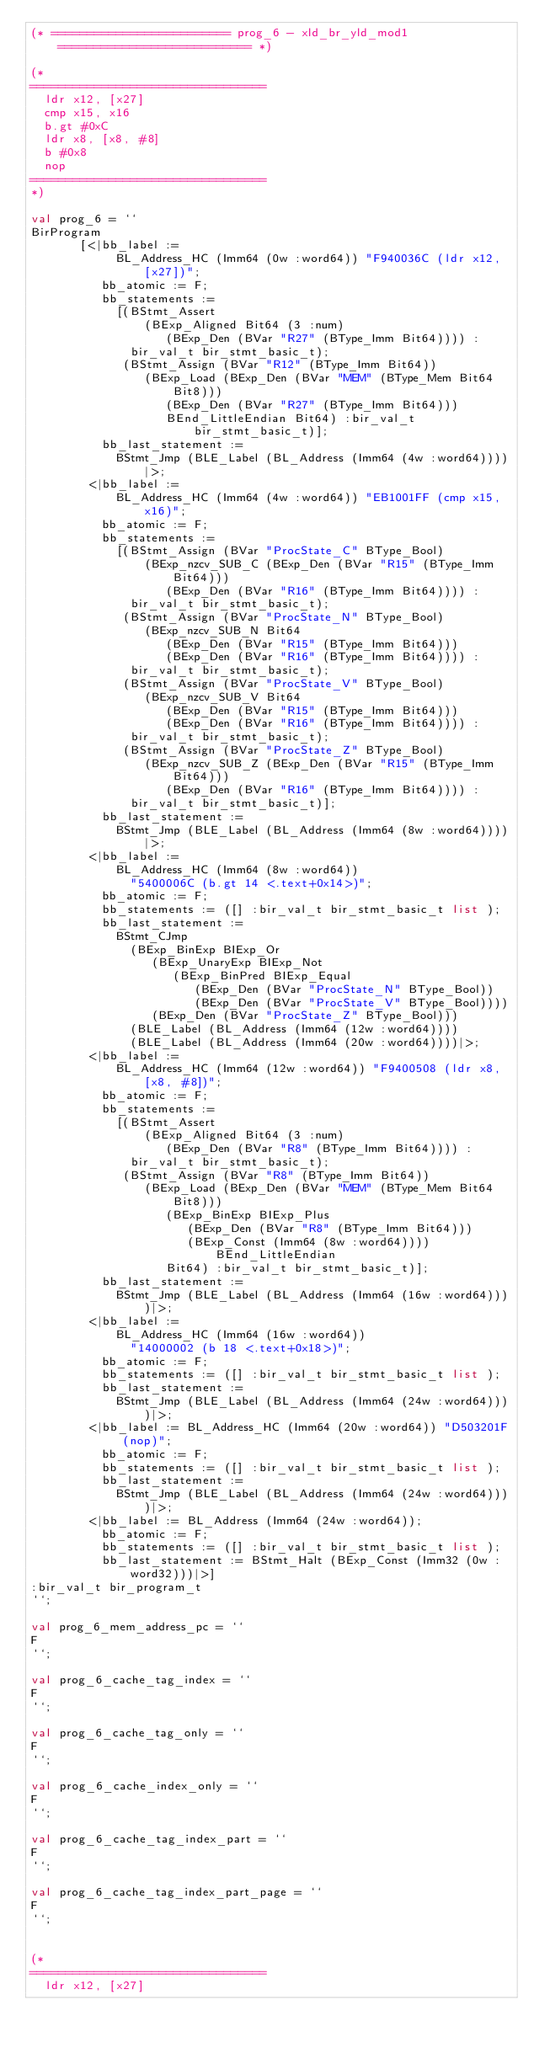<code> <loc_0><loc_0><loc_500><loc_500><_SML_>(* ========================= prog_6 - xld_br_yld_mod1 =========================== *)

(*
=================================
	ldr x12, [x27]
	cmp x15, x16
	b.gt #0xC
	ldr x8, [x8, #8]
	b #0x8
	nop
=================================
*)

val prog_6 = ``
BirProgram
       [<|bb_label :=
            BL_Address_HC (Imm64 (0w :word64)) "F940036C (ldr x12, [x27])";
          bb_atomic := F;
          bb_statements :=
            [(BStmt_Assert
                (BExp_Aligned Bit64 (3 :num)
                   (BExp_Den (BVar "R27" (BType_Imm Bit64)))) :
              bir_val_t bir_stmt_basic_t);
             (BStmt_Assign (BVar "R12" (BType_Imm Bit64))
                (BExp_Load (BExp_Den (BVar "MEM" (BType_Mem Bit64 Bit8)))
                   (BExp_Den (BVar "R27" (BType_Imm Bit64)))
                   BEnd_LittleEndian Bit64) :bir_val_t bir_stmt_basic_t)];
          bb_last_statement :=
            BStmt_Jmp (BLE_Label (BL_Address (Imm64 (4w :word64))))|>;
        <|bb_label :=
            BL_Address_HC (Imm64 (4w :word64)) "EB1001FF (cmp x15, x16)";
          bb_atomic := F;
          bb_statements :=
            [(BStmt_Assign (BVar "ProcState_C" BType_Bool)
                (BExp_nzcv_SUB_C (BExp_Den (BVar "R15" (BType_Imm Bit64)))
                   (BExp_Den (BVar "R16" (BType_Imm Bit64)))) :
              bir_val_t bir_stmt_basic_t);
             (BStmt_Assign (BVar "ProcState_N" BType_Bool)
                (BExp_nzcv_SUB_N Bit64
                   (BExp_Den (BVar "R15" (BType_Imm Bit64)))
                   (BExp_Den (BVar "R16" (BType_Imm Bit64)))) :
              bir_val_t bir_stmt_basic_t);
             (BStmt_Assign (BVar "ProcState_V" BType_Bool)
                (BExp_nzcv_SUB_V Bit64
                   (BExp_Den (BVar "R15" (BType_Imm Bit64)))
                   (BExp_Den (BVar "R16" (BType_Imm Bit64)))) :
              bir_val_t bir_stmt_basic_t);
             (BStmt_Assign (BVar "ProcState_Z" BType_Bool)
                (BExp_nzcv_SUB_Z (BExp_Den (BVar "R15" (BType_Imm Bit64)))
                   (BExp_Den (BVar "R16" (BType_Imm Bit64)))) :
              bir_val_t bir_stmt_basic_t)];
          bb_last_statement :=
            BStmt_Jmp (BLE_Label (BL_Address (Imm64 (8w :word64))))|>;
        <|bb_label :=
            BL_Address_HC (Imm64 (8w :word64))
              "5400006C (b.gt 14 <.text+0x14>)";
          bb_atomic := F;
          bb_statements := ([] :bir_val_t bir_stmt_basic_t list );
          bb_last_statement :=
            BStmt_CJmp
              (BExp_BinExp BIExp_Or
                 (BExp_UnaryExp BIExp_Not
                    (BExp_BinPred BIExp_Equal
                       (BExp_Den (BVar "ProcState_N" BType_Bool))
                       (BExp_Den (BVar "ProcState_V" BType_Bool))))
                 (BExp_Den (BVar "ProcState_Z" BType_Bool)))
              (BLE_Label (BL_Address (Imm64 (12w :word64))))
              (BLE_Label (BL_Address (Imm64 (20w :word64))))|>;
        <|bb_label :=
            BL_Address_HC (Imm64 (12w :word64)) "F9400508 (ldr x8, [x8, #8])";
          bb_atomic := F;
          bb_statements :=
            [(BStmt_Assert
                (BExp_Aligned Bit64 (3 :num)
                   (BExp_Den (BVar "R8" (BType_Imm Bit64)))) :
              bir_val_t bir_stmt_basic_t);
             (BStmt_Assign (BVar "R8" (BType_Imm Bit64))
                (BExp_Load (BExp_Den (BVar "MEM" (BType_Mem Bit64 Bit8)))
                   (BExp_BinExp BIExp_Plus
                      (BExp_Den (BVar "R8" (BType_Imm Bit64)))
                      (BExp_Const (Imm64 (8w :word64)))) BEnd_LittleEndian
                   Bit64) :bir_val_t bir_stmt_basic_t)];
          bb_last_statement :=
            BStmt_Jmp (BLE_Label (BL_Address (Imm64 (16w :word64))))|>;
        <|bb_label :=
            BL_Address_HC (Imm64 (16w :word64))
              "14000002 (b 18 <.text+0x18>)";
          bb_atomic := F;
          bb_statements := ([] :bir_val_t bir_stmt_basic_t list );
          bb_last_statement :=
            BStmt_Jmp (BLE_Label (BL_Address (Imm64 (24w :word64))))|>;
        <|bb_label := BL_Address_HC (Imm64 (20w :word64)) "D503201F (nop)";
          bb_atomic := F;
          bb_statements := ([] :bir_val_t bir_stmt_basic_t list );
          bb_last_statement :=
            BStmt_Jmp (BLE_Label (BL_Address (Imm64 (24w :word64))))|>;
        <|bb_label := BL_Address (Imm64 (24w :word64));
          bb_atomic := F;
          bb_statements := ([] :bir_val_t bir_stmt_basic_t list );
          bb_last_statement := BStmt_Halt (BExp_Const (Imm32 (0w :word32)))|>]
:bir_val_t bir_program_t
``;

val prog_6_mem_address_pc = ``
F
``;

val prog_6_cache_tag_index = ``
F
``;

val prog_6_cache_tag_only = ``
F
``;

val prog_6_cache_index_only = ``
F
``;

val prog_6_cache_tag_index_part = ``
F
``;

val prog_6_cache_tag_index_part_page = ``
F
``;


(*
=================================
	ldr x12, [x27]</code> 